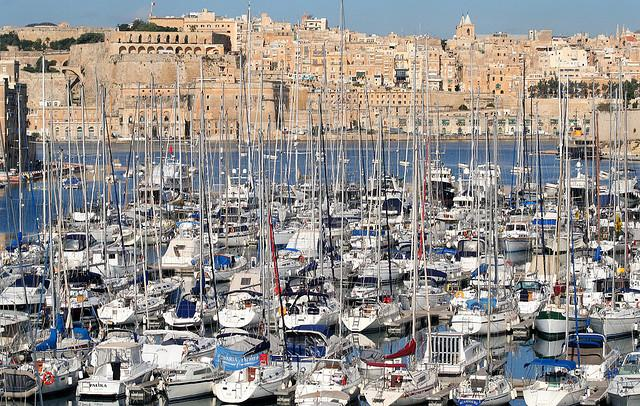What is a group of these abundant items called?

Choices:
A) clowder
B) bushel
C) fleet
D) squad fleet 